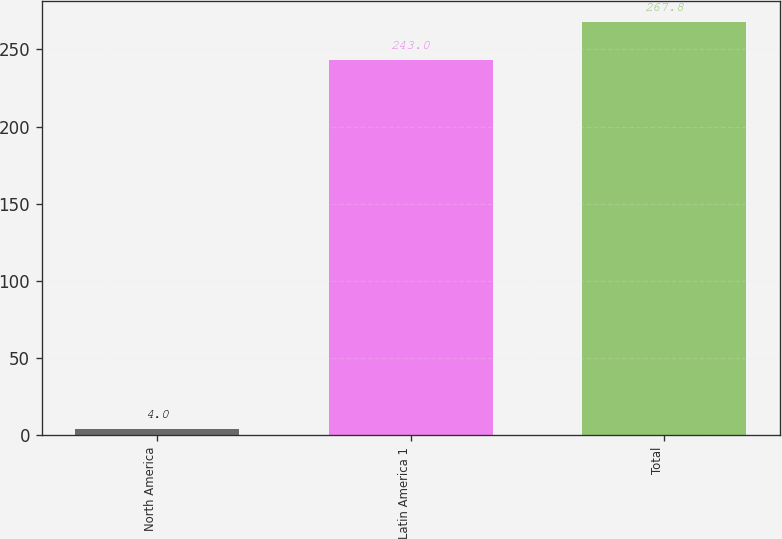Convert chart to OTSL. <chart><loc_0><loc_0><loc_500><loc_500><bar_chart><fcel>North America<fcel>Latin America 1<fcel>Total<nl><fcel>4<fcel>243<fcel>267.8<nl></chart> 